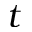Convert formula to latex. <formula><loc_0><loc_0><loc_500><loc_500>t</formula> 